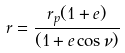<formula> <loc_0><loc_0><loc_500><loc_500>r = \frac { r _ { p } ( 1 + e ) } { ( 1 + e \cos \nu ) }</formula> 